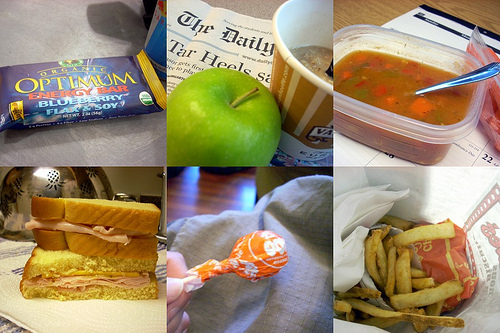Please transcribe the text information in this image. SOY ENERGY ORGANIC FLAX 22 S Heels Tar DAILY The OPTIMUM 